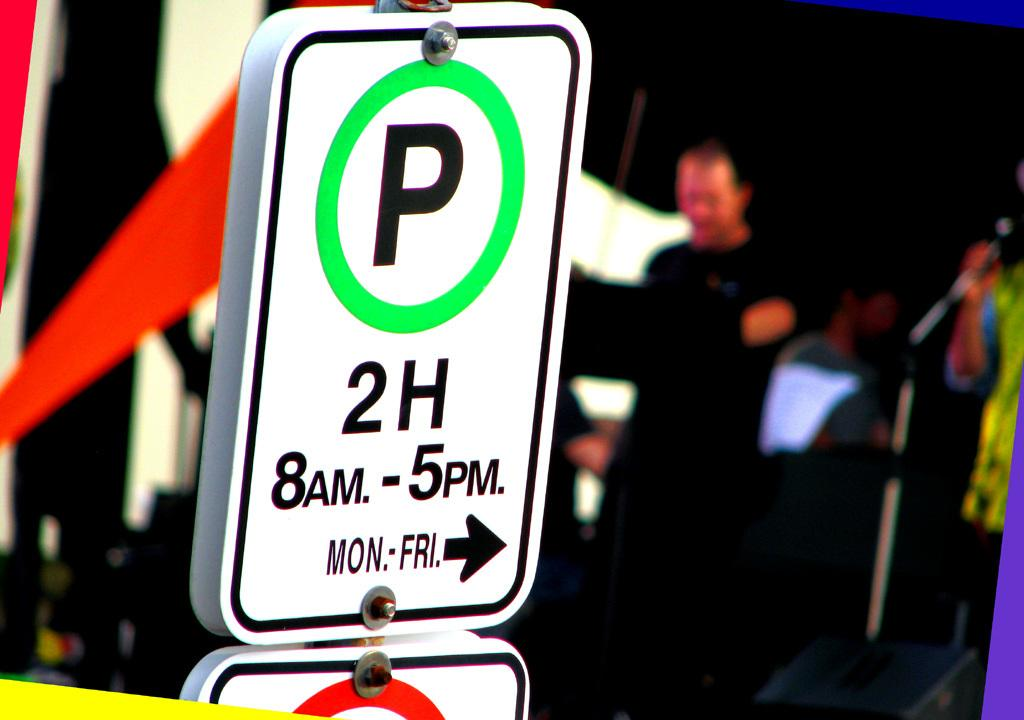<image>
Provide a brief description of the given image. A parking sign enforces a two hour parking limit. 